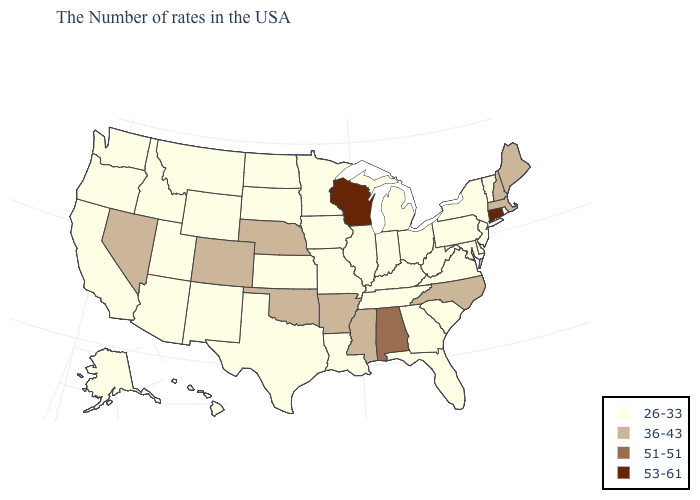Name the states that have a value in the range 36-43?
Give a very brief answer. Maine, Massachusetts, New Hampshire, North Carolina, Mississippi, Arkansas, Nebraska, Oklahoma, Colorado, Nevada. Which states have the lowest value in the West?
Be succinct. Wyoming, New Mexico, Utah, Montana, Arizona, Idaho, California, Washington, Oregon, Alaska, Hawaii. What is the value of Idaho?
Answer briefly. 26-33. Does the map have missing data?
Answer briefly. No. Does Colorado have the lowest value in the West?
Concise answer only. No. Among the states that border Arizona , does New Mexico have the highest value?
Concise answer only. No. Does Ohio have the same value as Kansas?
Be succinct. Yes. Name the states that have a value in the range 51-51?
Short answer required. Alabama. What is the value of Connecticut?
Keep it brief. 53-61. Which states have the lowest value in the USA?
Give a very brief answer. Rhode Island, Vermont, New York, New Jersey, Delaware, Maryland, Pennsylvania, Virginia, South Carolina, West Virginia, Ohio, Florida, Georgia, Michigan, Kentucky, Indiana, Tennessee, Illinois, Louisiana, Missouri, Minnesota, Iowa, Kansas, Texas, South Dakota, North Dakota, Wyoming, New Mexico, Utah, Montana, Arizona, Idaho, California, Washington, Oregon, Alaska, Hawaii. Name the states that have a value in the range 26-33?
Concise answer only. Rhode Island, Vermont, New York, New Jersey, Delaware, Maryland, Pennsylvania, Virginia, South Carolina, West Virginia, Ohio, Florida, Georgia, Michigan, Kentucky, Indiana, Tennessee, Illinois, Louisiana, Missouri, Minnesota, Iowa, Kansas, Texas, South Dakota, North Dakota, Wyoming, New Mexico, Utah, Montana, Arizona, Idaho, California, Washington, Oregon, Alaska, Hawaii. Name the states that have a value in the range 36-43?
Concise answer only. Maine, Massachusetts, New Hampshire, North Carolina, Mississippi, Arkansas, Nebraska, Oklahoma, Colorado, Nevada. Does Maryland have the same value as North Carolina?
Answer briefly. No. What is the value of South Carolina?
Keep it brief. 26-33. What is the highest value in states that border North Carolina?
Write a very short answer. 26-33. 